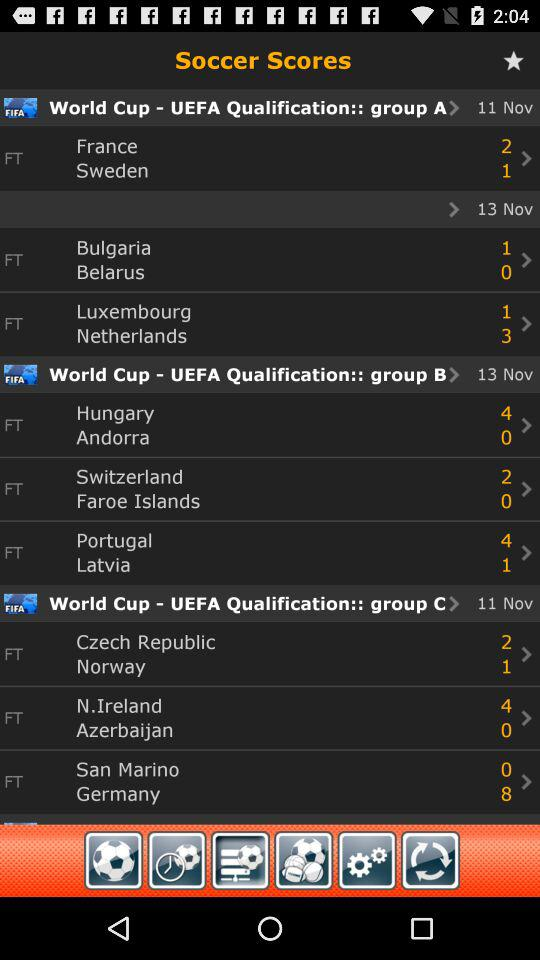On which date was the match between "France" and "Sweden" held? The match between "France" and "Sweden" was held on November 11. 